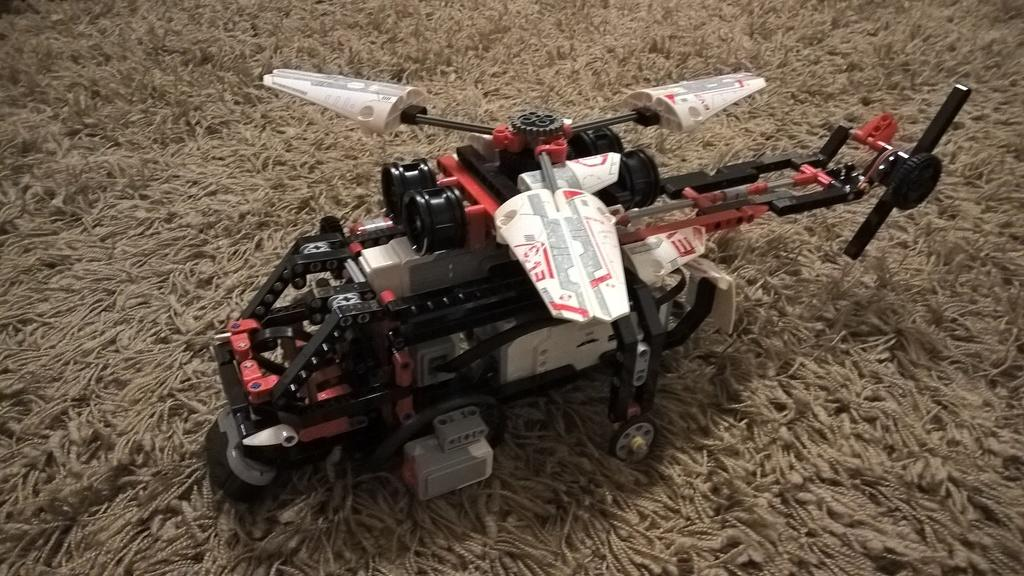What is the main object in the image? There is a toy helicopter in the image. What is the toy helicopter placed on? The toy helicopter is on a woolen mat. What type of seed is growing next to the toy helicopter in the image? There is no seed or plant visible in the image; it only features a toy helicopter on a woolen mat. 